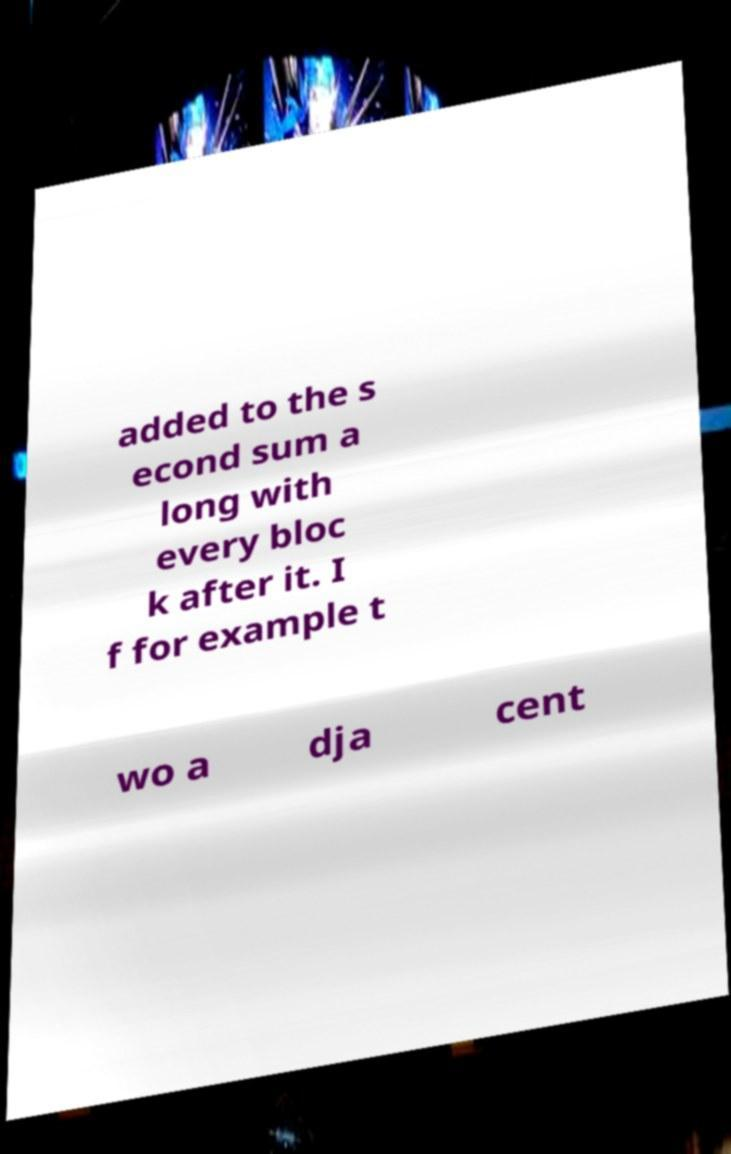For documentation purposes, I need the text within this image transcribed. Could you provide that? added to the s econd sum a long with every bloc k after it. I f for example t wo a dja cent 